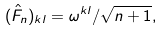Convert formula to latex. <formula><loc_0><loc_0><loc_500><loc_500>( \hat { F } _ { n } ) _ { k l } = \omega ^ { k l } / \sqrt { n + 1 } ,</formula> 